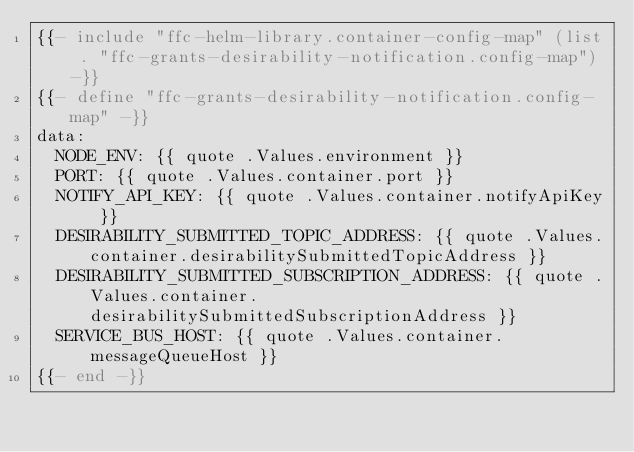<code> <loc_0><loc_0><loc_500><loc_500><_YAML_>{{- include "ffc-helm-library.container-config-map" (list . "ffc-grants-desirability-notification.config-map") -}}
{{- define "ffc-grants-desirability-notification.config-map" -}}
data:
  NODE_ENV: {{ quote .Values.environment }}
  PORT: {{ quote .Values.container.port }}
  NOTIFY_API_KEY: {{ quote .Values.container.notifyApiKey }}
  DESIRABILITY_SUBMITTED_TOPIC_ADDRESS: {{ quote .Values.container.desirabilitySubmittedTopicAddress }}
  DESIRABILITY_SUBMITTED_SUBSCRIPTION_ADDRESS: {{ quote .Values.container.desirabilitySubmittedSubscriptionAddress }}
  SERVICE_BUS_HOST: {{ quote .Values.container.messageQueueHost }}
{{- end -}}
</code> 